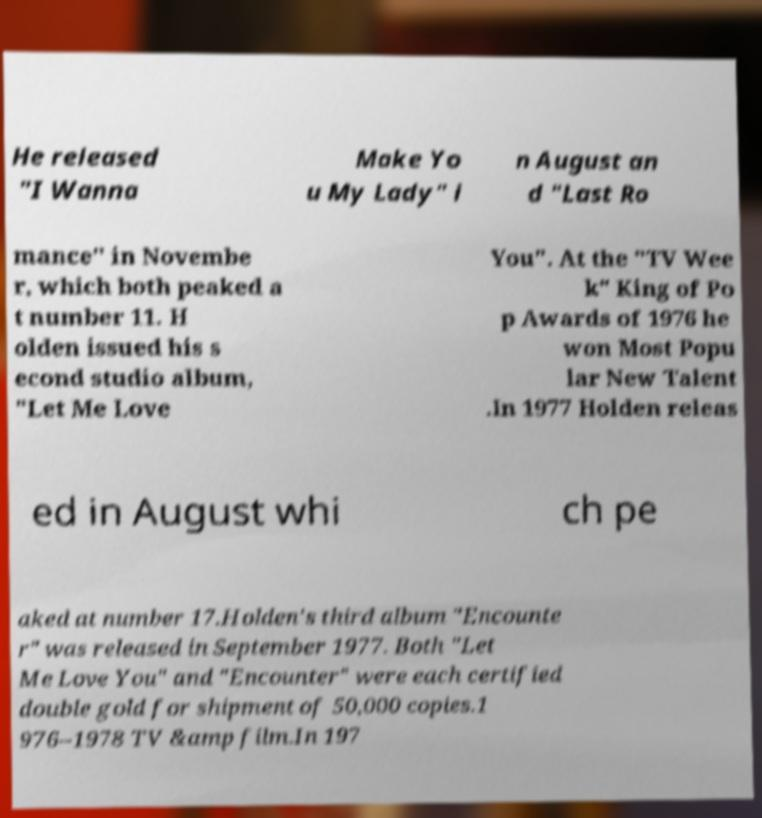Could you extract and type out the text from this image? He released "I Wanna Make Yo u My Lady" i n August an d "Last Ro mance" in Novembe r, which both peaked a t number 11. H olden issued his s econd studio album, "Let Me Love You". At the "TV Wee k" King of Po p Awards of 1976 he won Most Popu lar New Talent .In 1977 Holden releas ed in August whi ch pe aked at number 17.Holden's third album "Encounte r" was released in September 1977. Both "Let Me Love You" and "Encounter" were each certified double gold for shipment of 50,000 copies.1 976–1978 TV &amp film.In 197 